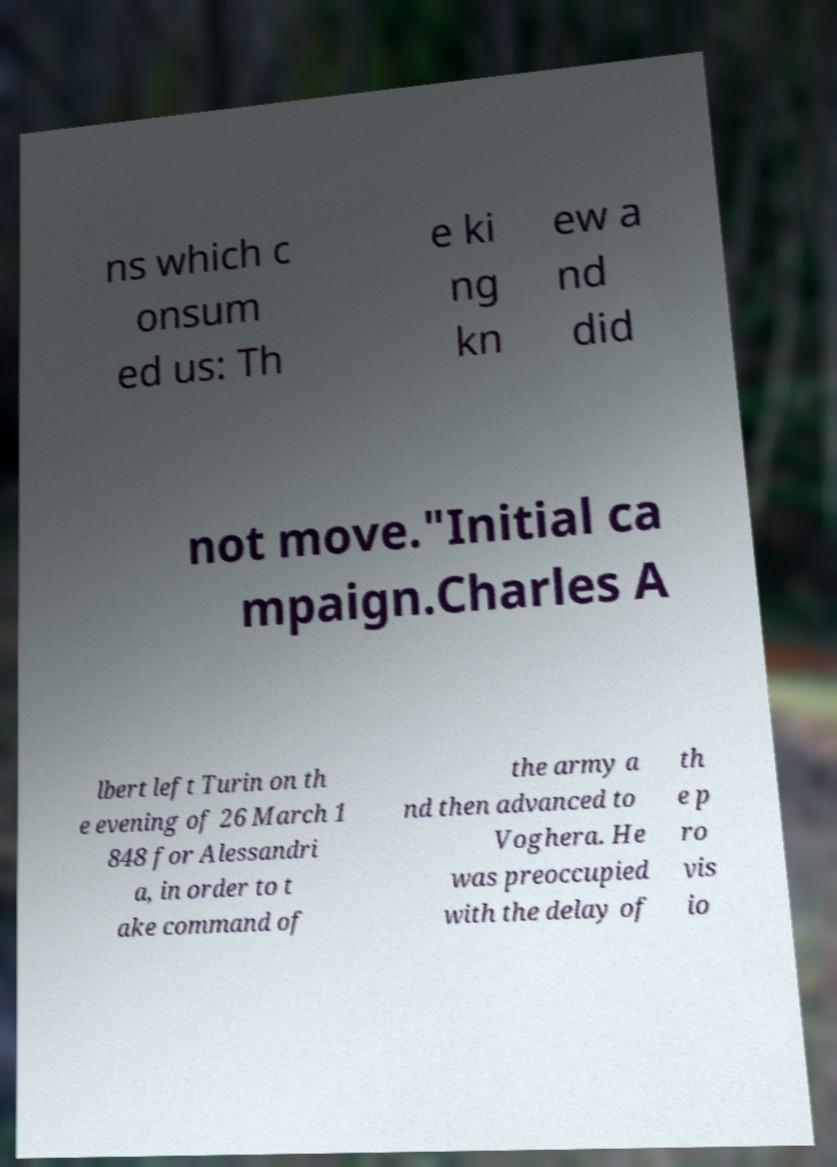Can you read and provide the text displayed in the image?This photo seems to have some interesting text. Can you extract and type it out for me? ns which c onsum ed us: Th e ki ng kn ew a nd did not move."Initial ca mpaign.Charles A lbert left Turin on th e evening of 26 March 1 848 for Alessandri a, in order to t ake command of the army a nd then advanced to Voghera. He was preoccupied with the delay of th e p ro vis io 